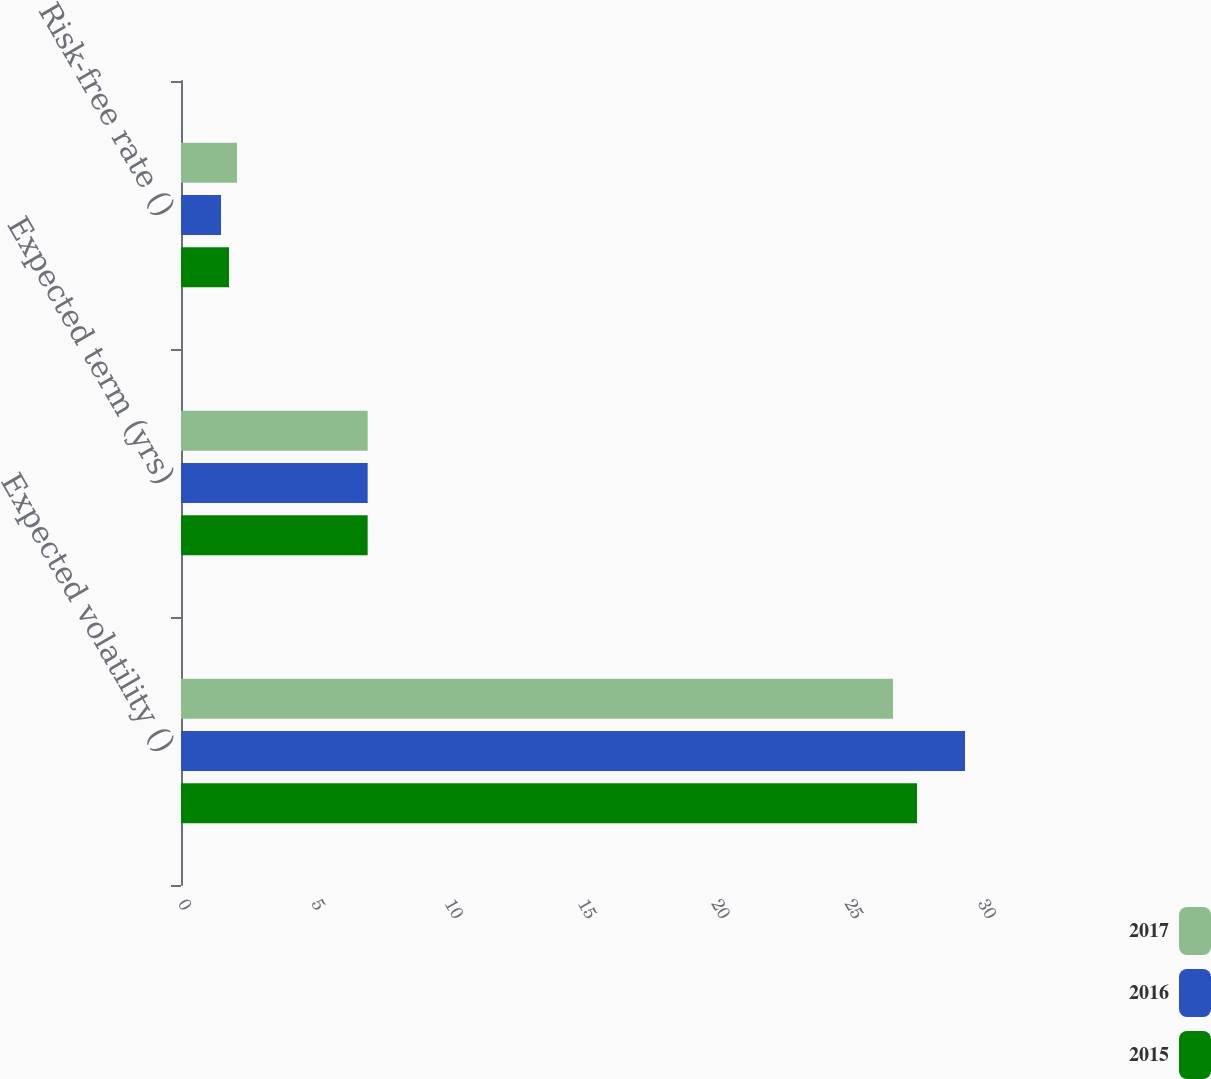Convert chart to OTSL. <chart><loc_0><loc_0><loc_500><loc_500><stacked_bar_chart><ecel><fcel>Expected volatility ()<fcel>Expected term (yrs)<fcel>Risk-free rate ()<nl><fcel>2017<fcel>26.7<fcel>7<fcel>2.1<nl><fcel>2016<fcel>29.4<fcel>7<fcel>1.5<nl><fcel>2015<fcel>27.6<fcel>7<fcel>1.8<nl></chart> 